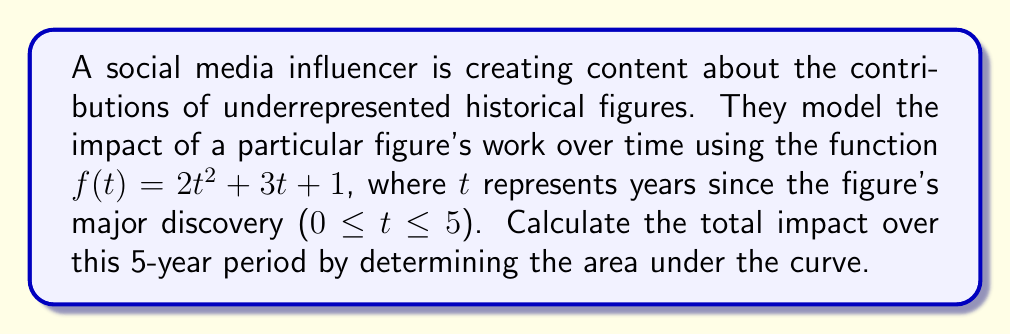Give your solution to this math problem. To find the area under the curve, we need to integrate the function $f(t) = 2t^2 + 3t + 1$ from $t = 0$ to $t = 5$. Let's follow these steps:

1) Set up the definite integral:
   $$\int_0^5 (2t^2 + 3t + 1) dt$$

2) Integrate the function:
   $$\left[ \frac{2t^3}{3} + \frac{3t^2}{2} + t \right]_0^5$$

3) Evaluate the integral at the upper and lower bounds:
   $$\left( \frac{2(5^3)}{3} + \frac{3(5^2)}{2} + 5 \right) - \left( \frac{2(0^3)}{3} + \frac{3(0^2)}{2} + 0 \right)$$

4) Simplify:
   $$\left( \frac{250}{3} + \frac{75}{2} + 5 \right) - 0$$

5) Calculate:
   $$\frac{250}{3} + \frac{75}{2} + 5 = 83.33 + 37.5 + 5 = 125.83$$

The area under the curve, representing the total impact over the 5-year period, is approximately 125.83 units.
Answer: 125.83 units 